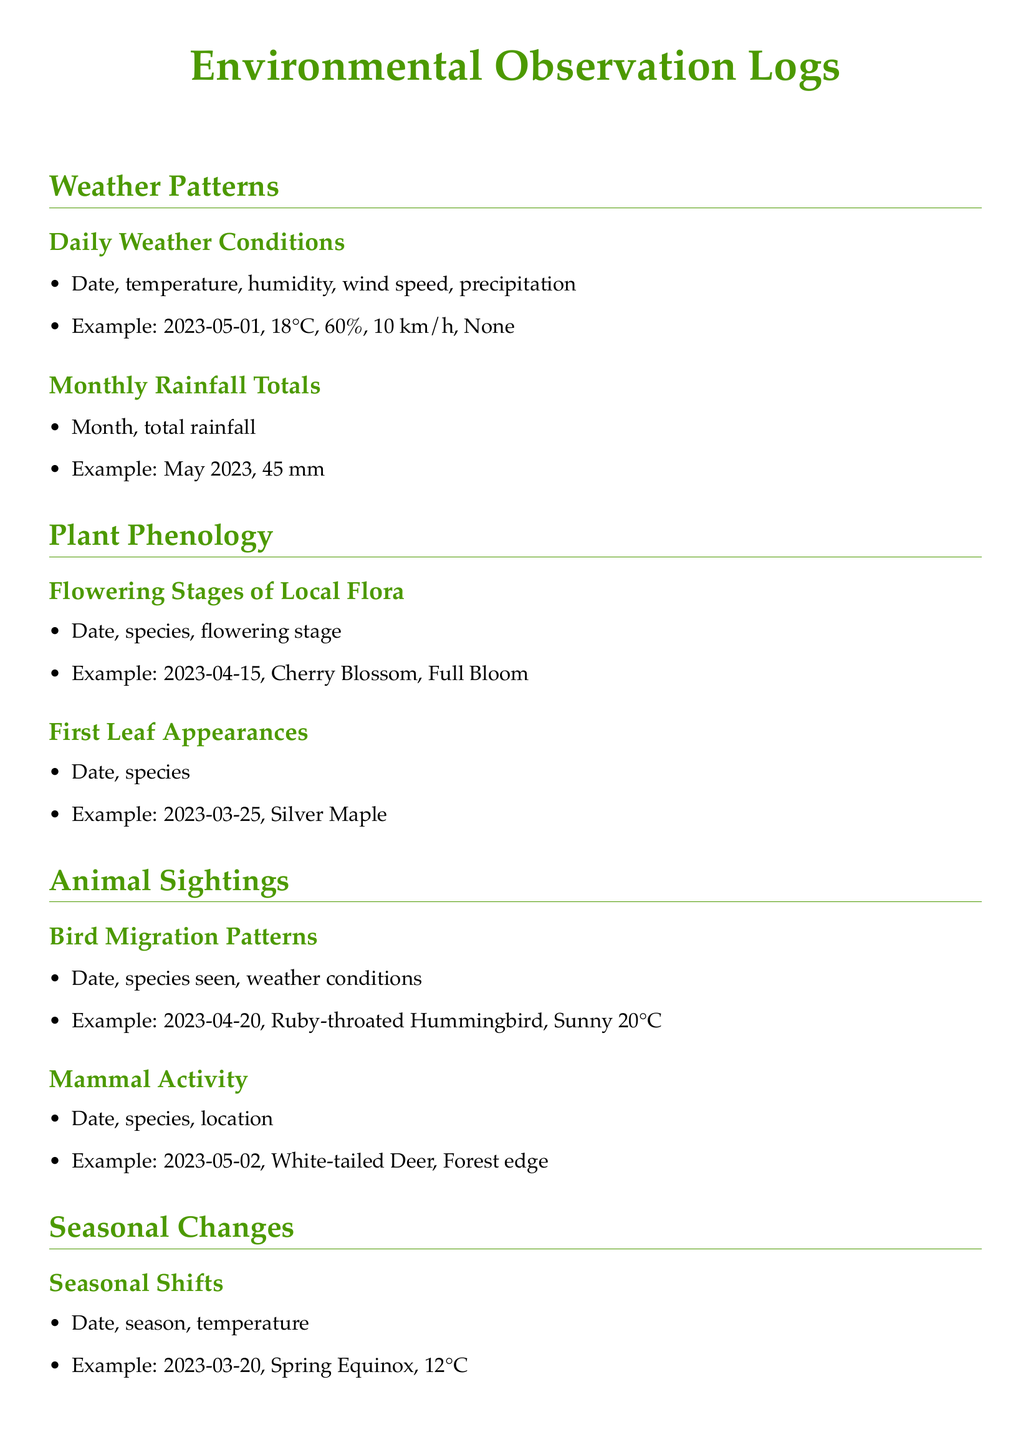What date was the first leaf appearance recorded? The example shows the first leaf appearance for the Silver Maple on March 25, 2023.
Answer: 2023-03-25 What type of bird was seen migrating on April 20, 2023? The entry specifies that on April 20, 2023, the Ruby-throated Hummingbird was recorded.
Answer: Ruby-throated Hummingbird What flowering stage was observed for Cherry Blossom on April 15, 2023? The document states that on April 15, 2023, the Cherry Blossom was in Full Bloom.
Answer: Full Bloom What is the total rainfall for May 2023? According to the example in the logs, the total rainfall for May 2023 was 45 mm.
Answer: 45 mm What was the temperature recorded on the Spring Equinox (March 20, 2023)? The document notes the temperature on March 20, 2023, was 12°C during the Spring Equinox.
Answer: 12°C How many observations are listed under Plant Phenology? The 'Plant Phenology' section contains two types of observations: Flowering Stages of Local Flora and First Leaf Appearances.
Answer: 2 Which seasonal shift is specifically noted in the logs? The document mentions specific observations related to the Spring Equinox.
Answer: Spring Equinox What species is noted for its early color change on October 5, 2023? The log indicates that the Sugar Maple showed an Early Color Change on October 5, 2023.
Answer: Sugar Maple 